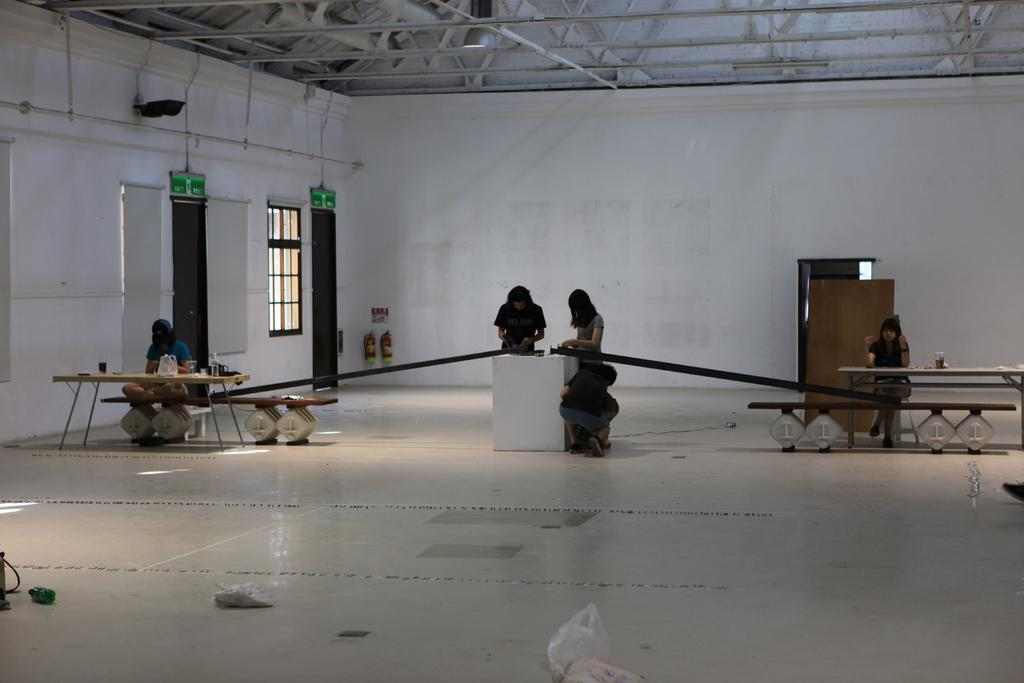Where was the image taken? The image was taken inside a hall. How many women are present in the image? There are six women in the image. What can be seen on the left side of the image? There is a wall with windows and doors on the left side of the image. What is the structure of the roof in the image? The roof is made up of stands at the top of the image. What type of engine can be seen powering the hall in the image? There is no engine present in the image; it is a hall with women and a wall with windows and doors. 